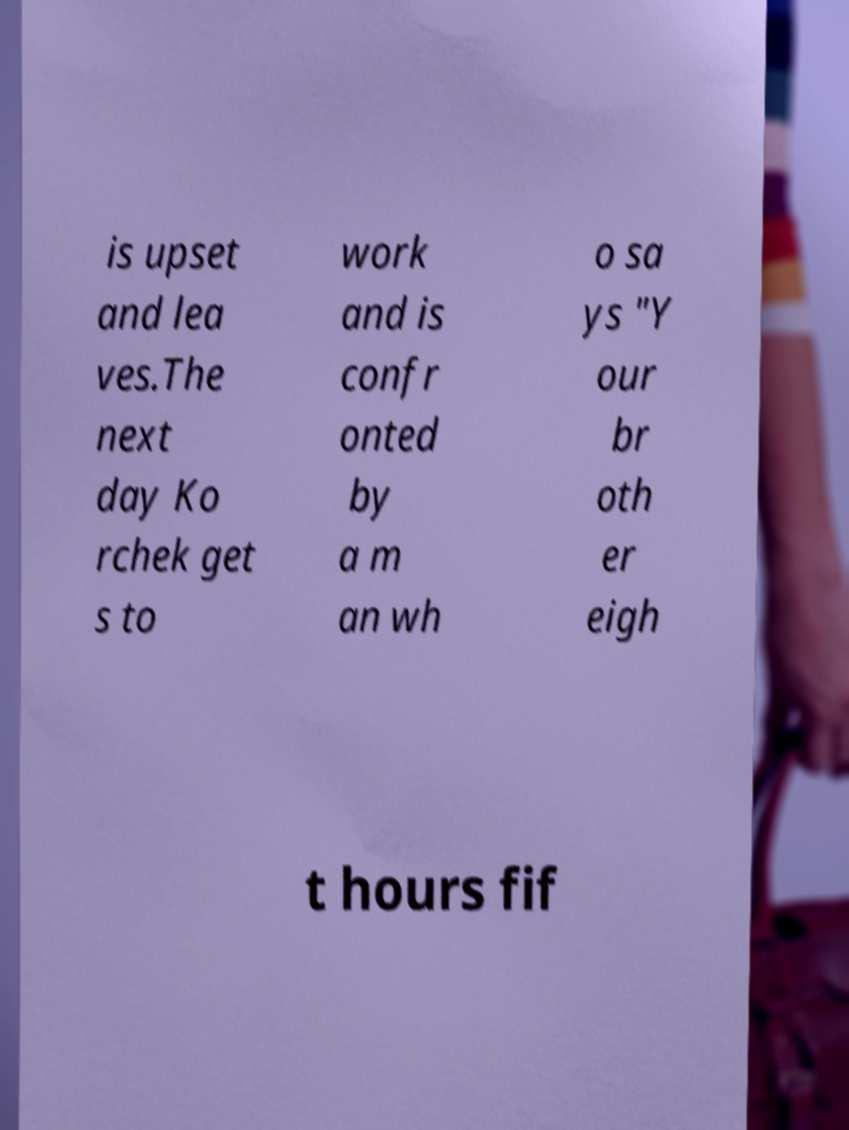Can you read and provide the text displayed in the image?This photo seems to have some interesting text. Can you extract and type it out for me? is upset and lea ves.The next day Ko rchek get s to work and is confr onted by a m an wh o sa ys "Y our br oth er eigh t hours fif 